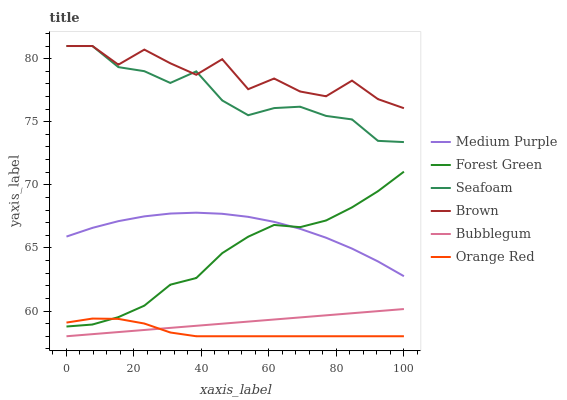Does Orange Red have the minimum area under the curve?
Answer yes or no. Yes. Does Brown have the maximum area under the curve?
Answer yes or no. Yes. Does Seafoam have the minimum area under the curve?
Answer yes or no. No. Does Seafoam have the maximum area under the curve?
Answer yes or no. No. Is Bubblegum the smoothest?
Answer yes or no. Yes. Is Brown the roughest?
Answer yes or no. Yes. Is Seafoam the smoothest?
Answer yes or no. No. Is Seafoam the roughest?
Answer yes or no. No. Does Bubblegum have the lowest value?
Answer yes or no. Yes. Does Seafoam have the lowest value?
Answer yes or no. No. Does Seafoam have the highest value?
Answer yes or no. Yes. Does Bubblegum have the highest value?
Answer yes or no. No. Is Medium Purple less than Seafoam?
Answer yes or no. Yes. Is Brown greater than Forest Green?
Answer yes or no. Yes. Does Forest Green intersect Medium Purple?
Answer yes or no. Yes. Is Forest Green less than Medium Purple?
Answer yes or no. No. Is Forest Green greater than Medium Purple?
Answer yes or no. No. Does Medium Purple intersect Seafoam?
Answer yes or no. No. 